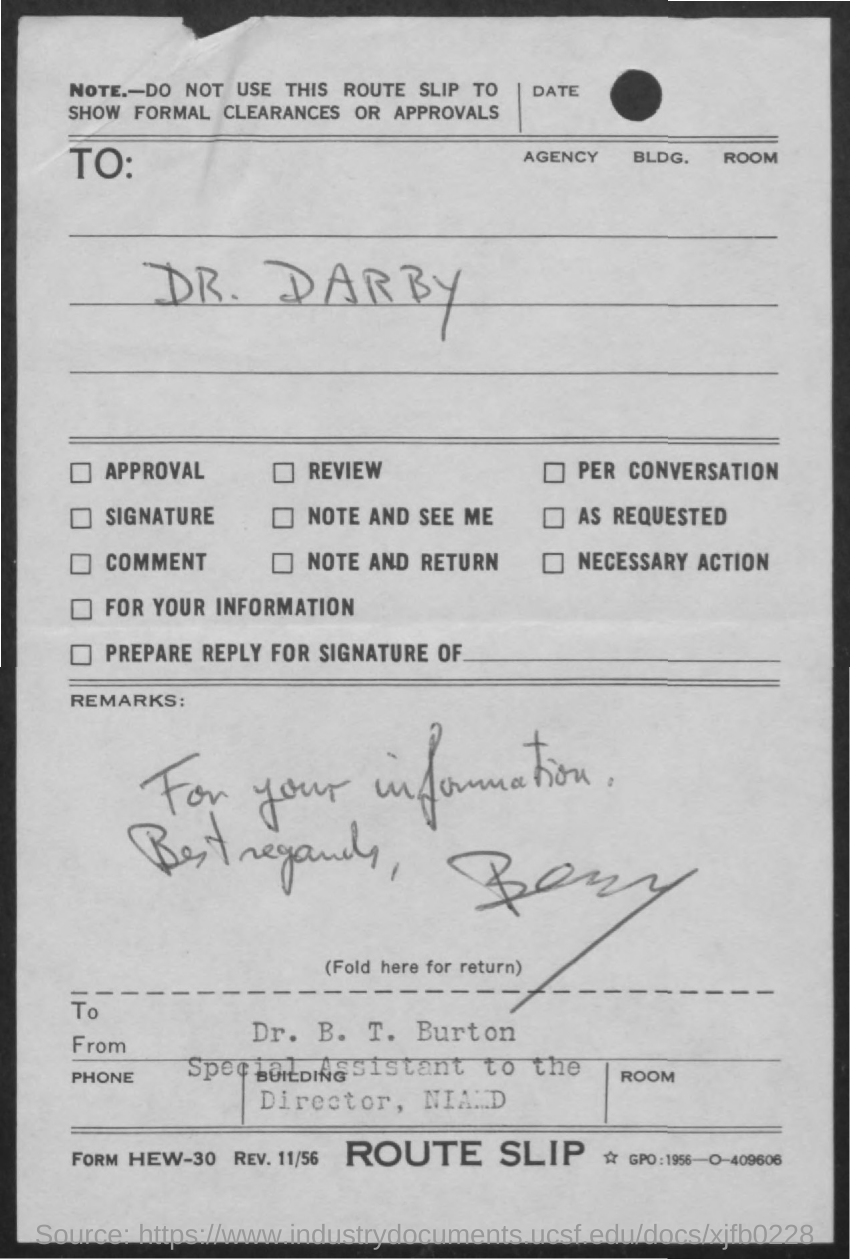Identify some key points in this picture. The letter is addressed to Dr. Darby. The letter is from Dr. B. T. Burton. 